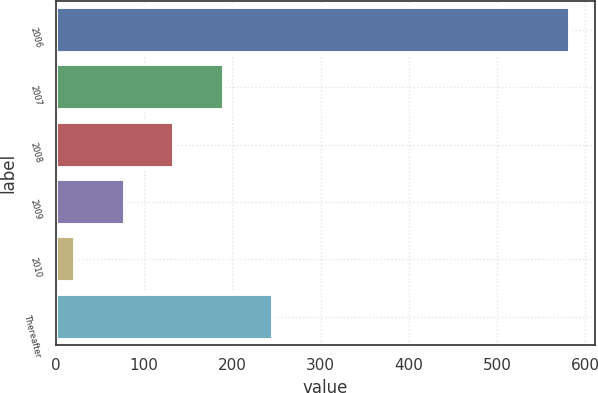Convert chart. <chart><loc_0><loc_0><loc_500><loc_500><bar_chart><fcel>2006<fcel>2007<fcel>2008<fcel>2009<fcel>2010<fcel>Thereafter<nl><fcel>582<fcel>190<fcel>134<fcel>78<fcel>22<fcel>246<nl></chart> 